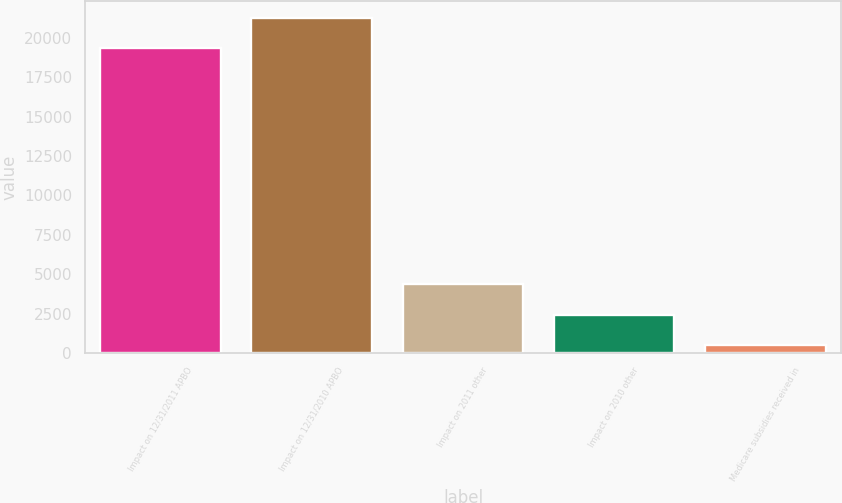Convert chart to OTSL. <chart><loc_0><loc_0><loc_500><loc_500><bar_chart><fcel>Impact on 12/31/2011 APBO<fcel>Impact on 12/31/2010 APBO<fcel>Impact on 2011 other<fcel>Impact on 2010 other<fcel>Medicare subsidies received in<nl><fcel>19346<fcel>21280.1<fcel>4357.2<fcel>2423.1<fcel>489<nl></chart> 